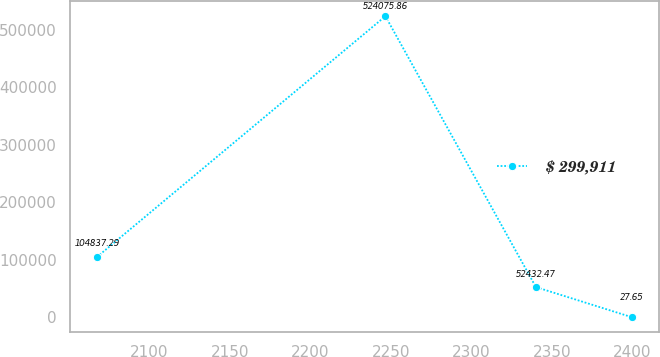Convert chart to OTSL. <chart><loc_0><loc_0><loc_500><loc_500><line_chart><ecel><fcel>$ 299,911<nl><fcel>2067.36<fcel>104837<nl><fcel>2246.56<fcel>524076<nl><fcel>2340.08<fcel>52432.5<nl><fcel>2399.65<fcel>27.65<nl></chart> 